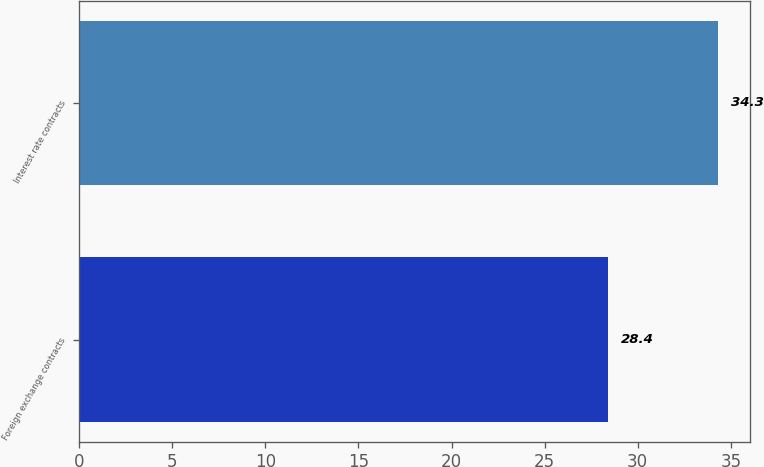Convert chart to OTSL. <chart><loc_0><loc_0><loc_500><loc_500><bar_chart><fcel>Foreign exchange contracts<fcel>Interest rate contracts<nl><fcel>28.4<fcel>34.3<nl></chart> 